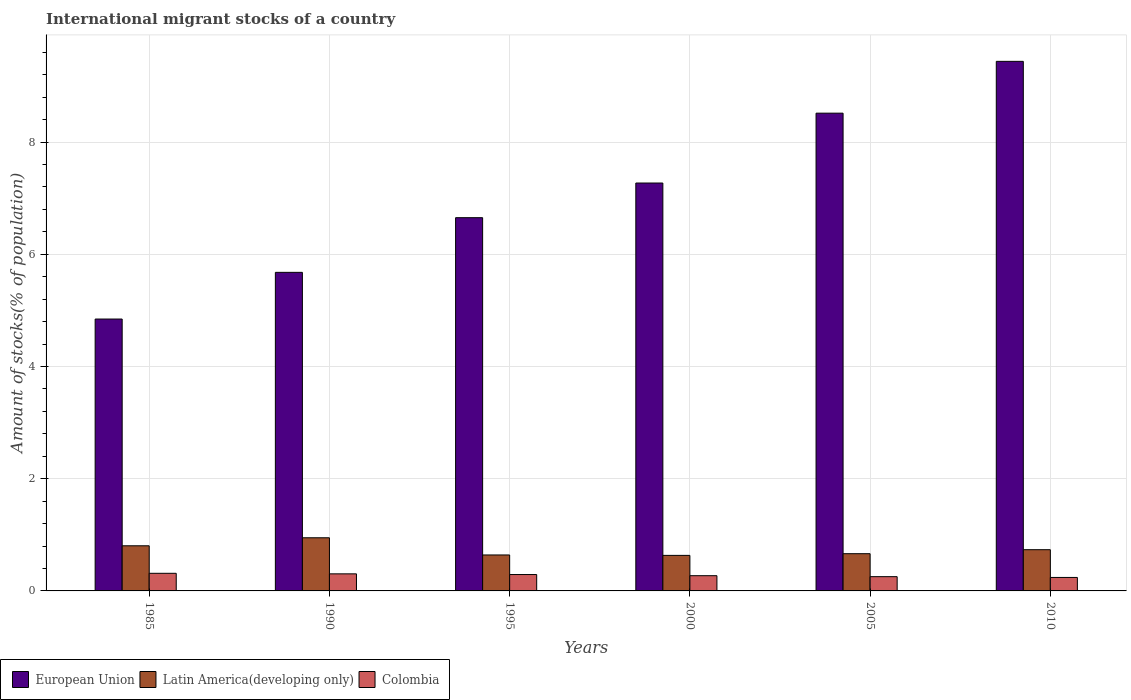How many different coloured bars are there?
Keep it short and to the point. 3. Are the number of bars on each tick of the X-axis equal?
Your response must be concise. Yes. How many bars are there on the 4th tick from the right?
Provide a short and direct response. 3. What is the label of the 6th group of bars from the left?
Make the answer very short. 2010. In how many cases, is the number of bars for a given year not equal to the number of legend labels?
Keep it short and to the point. 0. What is the amount of stocks in in Colombia in 1990?
Give a very brief answer. 0.3. Across all years, what is the maximum amount of stocks in in Colombia?
Make the answer very short. 0.31. Across all years, what is the minimum amount of stocks in in European Union?
Offer a very short reply. 4.85. In which year was the amount of stocks in in European Union maximum?
Give a very brief answer. 2010. In which year was the amount of stocks in in Colombia minimum?
Ensure brevity in your answer.  2010. What is the total amount of stocks in in Colombia in the graph?
Ensure brevity in your answer.  1.68. What is the difference between the amount of stocks in in Latin America(developing only) in 2000 and that in 2010?
Provide a short and direct response. -0.1. What is the difference between the amount of stocks in in Colombia in 2005 and the amount of stocks in in Latin America(developing only) in 1990?
Ensure brevity in your answer.  -0.69. What is the average amount of stocks in in Colombia per year?
Provide a short and direct response. 0.28. In the year 2010, what is the difference between the amount of stocks in in Latin America(developing only) and amount of stocks in in Colombia?
Keep it short and to the point. 0.49. In how many years, is the amount of stocks in in European Union greater than 6 %?
Make the answer very short. 4. What is the ratio of the amount of stocks in in European Union in 1990 to that in 1995?
Your response must be concise. 0.85. Is the difference between the amount of stocks in in Latin America(developing only) in 1995 and 2000 greater than the difference between the amount of stocks in in Colombia in 1995 and 2000?
Keep it short and to the point. No. What is the difference between the highest and the second highest amount of stocks in in Colombia?
Provide a succinct answer. 0.01. What is the difference between the highest and the lowest amount of stocks in in European Union?
Offer a very short reply. 4.59. What does the 1st bar from the left in 1995 represents?
Ensure brevity in your answer.  European Union. What does the 2nd bar from the right in 1990 represents?
Give a very brief answer. Latin America(developing only). Is it the case that in every year, the sum of the amount of stocks in in European Union and amount of stocks in in Colombia is greater than the amount of stocks in in Latin America(developing only)?
Provide a short and direct response. Yes. How many bars are there?
Make the answer very short. 18. How many years are there in the graph?
Make the answer very short. 6. What is the difference between two consecutive major ticks on the Y-axis?
Offer a terse response. 2. Are the values on the major ticks of Y-axis written in scientific E-notation?
Provide a short and direct response. No. Does the graph contain any zero values?
Give a very brief answer. No. How are the legend labels stacked?
Keep it short and to the point. Horizontal. What is the title of the graph?
Your response must be concise. International migrant stocks of a country. Does "Venezuela" appear as one of the legend labels in the graph?
Provide a short and direct response. No. What is the label or title of the X-axis?
Your answer should be very brief. Years. What is the label or title of the Y-axis?
Ensure brevity in your answer.  Amount of stocks(% of population). What is the Amount of stocks(% of population) in European Union in 1985?
Your response must be concise. 4.85. What is the Amount of stocks(% of population) in Latin America(developing only) in 1985?
Your answer should be compact. 0.8. What is the Amount of stocks(% of population) in Colombia in 1985?
Offer a terse response. 0.31. What is the Amount of stocks(% of population) of European Union in 1990?
Keep it short and to the point. 5.68. What is the Amount of stocks(% of population) of Latin America(developing only) in 1990?
Offer a very short reply. 0.95. What is the Amount of stocks(% of population) in Colombia in 1990?
Ensure brevity in your answer.  0.3. What is the Amount of stocks(% of population) in European Union in 1995?
Offer a terse response. 6.65. What is the Amount of stocks(% of population) of Latin America(developing only) in 1995?
Your answer should be compact. 0.64. What is the Amount of stocks(% of population) of Colombia in 1995?
Offer a terse response. 0.29. What is the Amount of stocks(% of population) of European Union in 2000?
Your answer should be compact. 7.27. What is the Amount of stocks(% of population) of Latin America(developing only) in 2000?
Offer a terse response. 0.63. What is the Amount of stocks(% of population) in Colombia in 2000?
Provide a succinct answer. 0.27. What is the Amount of stocks(% of population) of European Union in 2005?
Offer a very short reply. 8.51. What is the Amount of stocks(% of population) in Latin America(developing only) in 2005?
Keep it short and to the point. 0.66. What is the Amount of stocks(% of population) of Colombia in 2005?
Offer a very short reply. 0.25. What is the Amount of stocks(% of population) in European Union in 2010?
Provide a short and direct response. 9.44. What is the Amount of stocks(% of population) in Latin America(developing only) in 2010?
Provide a short and direct response. 0.73. What is the Amount of stocks(% of population) in Colombia in 2010?
Keep it short and to the point. 0.24. Across all years, what is the maximum Amount of stocks(% of population) in European Union?
Your response must be concise. 9.44. Across all years, what is the maximum Amount of stocks(% of population) in Latin America(developing only)?
Keep it short and to the point. 0.95. Across all years, what is the maximum Amount of stocks(% of population) of Colombia?
Make the answer very short. 0.31. Across all years, what is the minimum Amount of stocks(% of population) of European Union?
Keep it short and to the point. 4.85. Across all years, what is the minimum Amount of stocks(% of population) of Latin America(developing only)?
Ensure brevity in your answer.  0.63. Across all years, what is the minimum Amount of stocks(% of population) in Colombia?
Offer a very short reply. 0.24. What is the total Amount of stocks(% of population) in European Union in the graph?
Offer a very short reply. 42.4. What is the total Amount of stocks(% of population) of Latin America(developing only) in the graph?
Your answer should be very brief. 4.42. What is the total Amount of stocks(% of population) of Colombia in the graph?
Provide a succinct answer. 1.68. What is the difference between the Amount of stocks(% of population) in European Union in 1985 and that in 1990?
Make the answer very short. -0.83. What is the difference between the Amount of stocks(% of population) of Latin America(developing only) in 1985 and that in 1990?
Keep it short and to the point. -0.14. What is the difference between the Amount of stocks(% of population) in Colombia in 1985 and that in 1990?
Your answer should be very brief. 0.01. What is the difference between the Amount of stocks(% of population) of European Union in 1985 and that in 1995?
Your answer should be very brief. -1.81. What is the difference between the Amount of stocks(% of population) in Latin America(developing only) in 1985 and that in 1995?
Offer a very short reply. 0.16. What is the difference between the Amount of stocks(% of population) of Colombia in 1985 and that in 1995?
Keep it short and to the point. 0.02. What is the difference between the Amount of stocks(% of population) in European Union in 1985 and that in 2000?
Provide a short and direct response. -2.42. What is the difference between the Amount of stocks(% of population) in Latin America(developing only) in 1985 and that in 2000?
Offer a very short reply. 0.17. What is the difference between the Amount of stocks(% of population) of Colombia in 1985 and that in 2000?
Keep it short and to the point. 0.04. What is the difference between the Amount of stocks(% of population) in European Union in 1985 and that in 2005?
Keep it short and to the point. -3.67. What is the difference between the Amount of stocks(% of population) in Latin America(developing only) in 1985 and that in 2005?
Your response must be concise. 0.14. What is the difference between the Amount of stocks(% of population) of Colombia in 1985 and that in 2005?
Your answer should be very brief. 0.06. What is the difference between the Amount of stocks(% of population) in European Union in 1985 and that in 2010?
Give a very brief answer. -4.59. What is the difference between the Amount of stocks(% of population) in Latin America(developing only) in 1985 and that in 2010?
Keep it short and to the point. 0.07. What is the difference between the Amount of stocks(% of population) of Colombia in 1985 and that in 2010?
Keep it short and to the point. 0.07. What is the difference between the Amount of stocks(% of population) in European Union in 1990 and that in 1995?
Your response must be concise. -0.97. What is the difference between the Amount of stocks(% of population) of Latin America(developing only) in 1990 and that in 1995?
Offer a very short reply. 0.31. What is the difference between the Amount of stocks(% of population) in Colombia in 1990 and that in 1995?
Give a very brief answer. 0.01. What is the difference between the Amount of stocks(% of population) in European Union in 1990 and that in 2000?
Your answer should be compact. -1.59. What is the difference between the Amount of stocks(% of population) of Latin America(developing only) in 1990 and that in 2000?
Provide a succinct answer. 0.31. What is the difference between the Amount of stocks(% of population) in Colombia in 1990 and that in 2000?
Provide a short and direct response. 0.03. What is the difference between the Amount of stocks(% of population) of European Union in 1990 and that in 2005?
Your answer should be very brief. -2.84. What is the difference between the Amount of stocks(% of population) in Latin America(developing only) in 1990 and that in 2005?
Your response must be concise. 0.28. What is the difference between the Amount of stocks(% of population) in Colombia in 1990 and that in 2005?
Give a very brief answer. 0.05. What is the difference between the Amount of stocks(% of population) of European Union in 1990 and that in 2010?
Provide a succinct answer. -3.76. What is the difference between the Amount of stocks(% of population) in Latin America(developing only) in 1990 and that in 2010?
Make the answer very short. 0.21. What is the difference between the Amount of stocks(% of population) in Colombia in 1990 and that in 2010?
Make the answer very short. 0.06. What is the difference between the Amount of stocks(% of population) in European Union in 1995 and that in 2000?
Make the answer very short. -0.62. What is the difference between the Amount of stocks(% of population) in Latin America(developing only) in 1995 and that in 2000?
Your response must be concise. 0.01. What is the difference between the Amount of stocks(% of population) of Colombia in 1995 and that in 2000?
Your answer should be compact. 0.02. What is the difference between the Amount of stocks(% of population) of European Union in 1995 and that in 2005?
Give a very brief answer. -1.86. What is the difference between the Amount of stocks(% of population) of Latin America(developing only) in 1995 and that in 2005?
Give a very brief answer. -0.02. What is the difference between the Amount of stocks(% of population) of Colombia in 1995 and that in 2005?
Give a very brief answer. 0.04. What is the difference between the Amount of stocks(% of population) of European Union in 1995 and that in 2010?
Your response must be concise. -2.79. What is the difference between the Amount of stocks(% of population) of Latin America(developing only) in 1995 and that in 2010?
Provide a short and direct response. -0.09. What is the difference between the Amount of stocks(% of population) of Colombia in 1995 and that in 2010?
Make the answer very short. 0.05. What is the difference between the Amount of stocks(% of population) in European Union in 2000 and that in 2005?
Provide a succinct answer. -1.25. What is the difference between the Amount of stocks(% of population) of Latin America(developing only) in 2000 and that in 2005?
Keep it short and to the point. -0.03. What is the difference between the Amount of stocks(% of population) in Colombia in 2000 and that in 2005?
Offer a terse response. 0.02. What is the difference between the Amount of stocks(% of population) in European Union in 2000 and that in 2010?
Make the answer very short. -2.17. What is the difference between the Amount of stocks(% of population) of Latin America(developing only) in 2000 and that in 2010?
Provide a succinct answer. -0.1. What is the difference between the Amount of stocks(% of population) of Colombia in 2000 and that in 2010?
Provide a succinct answer. 0.03. What is the difference between the Amount of stocks(% of population) of European Union in 2005 and that in 2010?
Make the answer very short. -0.92. What is the difference between the Amount of stocks(% of population) of Latin America(developing only) in 2005 and that in 2010?
Provide a short and direct response. -0.07. What is the difference between the Amount of stocks(% of population) in Colombia in 2005 and that in 2010?
Give a very brief answer. 0.01. What is the difference between the Amount of stocks(% of population) of European Union in 1985 and the Amount of stocks(% of population) of Latin America(developing only) in 1990?
Your answer should be very brief. 3.9. What is the difference between the Amount of stocks(% of population) in European Union in 1985 and the Amount of stocks(% of population) in Colombia in 1990?
Keep it short and to the point. 4.54. What is the difference between the Amount of stocks(% of population) in Latin America(developing only) in 1985 and the Amount of stocks(% of population) in Colombia in 1990?
Your answer should be very brief. 0.5. What is the difference between the Amount of stocks(% of population) of European Union in 1985 and the Amount of stocks(% of population) of Latin America(developing only) in 1995?
Your response must be concise. 4.2. What is the difference between the Amount of stocks(% of population) of European Union in 1985 and the Amount of stocks(% of population) of Colombia in 1995?
Make the answer very short. 4.55. What is the difference between the Amount of stocks(% of population) of Latin America(developing only) in 1985 and the Amount of stocks(% of population) of Colombia in 1995?
Give a very brief answer. 0.51. What is the difference between the Amount of stocks(% of population) of European Union in 1985 and the Amount of stocks(% of population) of Latin America(developing only) in 2000?
Offer a very short reply. 4.21. What is the difference between the Amount of stocks(% of population) in European Union in 1985 and the Amount of stocks(% of population) in Colombia in 2000?
Provide a short and direct response. 4.57. What is the difference between the Amount of stocks(% of population) in Latin America(developing only) in 1985 and the Amount of stocks(% of population) in Colombia in 2000?
Your response must be concise. 0.53. What is the difference between the Amount of stocks(% of population) of European Union in 1985 and the Amount of stocks(% of population) of Latin America(developing only) in 2005?
Your answer should be compact. 4.18. What is the difference between the Amount of stocks(% of population) in European Union in 1985 and the Amount of stocks(% of population) in Colombia in 2005?
Provide a succinct answer. 4.59. What is the difference between the Amount of stocks(% of population) of Latin America(developing only) in 1985 and the Amount of stocks(% of population) of Colombia in 2005?
Provide a short and direct response. 0.55. What is the difference between the Amount of stocks(% of population) in European Union in 1985 and the Amount of stocks(% of population) in Latin America(developing only) in 2010?
Offer a terse response. 4.11. What is the difference between the Amount of stocks(% of population) of European Union in 1985 and the Amount of stocks(% of population) of Colombia in 2010?
Keep it short and to the point. 4.61. What is the difference between the Amount of stocks(% of population) in Latin America(developing only) in 1985 and the Amount of stocks(% of population) in Colombia in 2010?
Provide a short and direct response. 0.56. What is the difference between the Amount of stocks(% of population) of European Union in 1990 and the Amount of stocks(% of population) of Latin America(developing only) in 1995?
Ensure brevity in your answer.  5.04. What is the difference between the Amount of stocks(% of population) in European Union in 1990 and the Amount of stocks(% of population) in Colombia in 1995?
Provide a short and direct response. 5.39. What is the difference between the Amount of stocks(% of population) in Latin America(developing only) in 1990 and the Amount of stocks(% of population) in Colombia in 1995?
Offer a terse response. 0.66. What is the difference between the Amount of stocks(% of population) in European Union in 1990 and the Amount of stocks(% of population) in Latin America(developing only) in 2000?
Your response must be concise. 5.04. What is the difference between the Amount of stocks(% of population) in European Union in 1990 and the Amount of stocks(% of population) in Colombia in 2000?
Provide a succinct answer. 5.41. What is the difference between the Amount of stocks(% of population) of Latin America(developing only) in 1990 and the Amount of stocks(% of population) of Colombia in 2000?
Offer a terse response. 0.68. What is the difference between the Amount of stocks(% of population) of European Union in 1990 and the Amount of stocks(% of population) of Latin America(developing only) in 2005?
Your answer should be compact. 5.01. What is the difference between the Amount of stocks(% of population) in European Union in 1990 and the Amount of stocks(% of population) in Colombia in 2005?
Give a very brief answer. 5.42. What is the difference between the Amount of stocks(% of population) of Latin America(developing only) in 1990 and the Amount of stocks(% of population) of Colombia in 2005?
Make the answer very short. 0.69. What is the difference between the Amount of stocks(% of population) of European Union in 1990 and the Amount of stocks(% of population) of Latin America(developing only) in 2010?
Offer a terse response. 4.94. What is the difference between the Amount of stocks(% of population) in European Union in 1990 and the Amount of stocks(% of population) in Colombia in 2010?
Keep it short and to the point. 5.44. What is the difference between the Amount of stocks(% of population) of Latin America(developing only) in 1990 and the Amount of stocks(% of population) of Colombia in 2010?
Your answer should be very brief. 0.71. What is the difference between the Amount of stocks(% of population) of European Union in 1995 and the Amount of stocks(% of population) of Latin America(developing only) in 2000?
Provide a short and direct response. 6.02. What is the difference between the Amount of stocks(% of population) in European Union in 1995 and the Amount of stocks(% of population) in Colombia in 2000?
Provide a succinct answer. 6.38. What is the difference between the Amount of stocks(% of population) in Latin America(developing only) in 1995 and the Amount of stocks(% of population) in Colombia in 2000?
Offer a terse response. 0.37. What is the difference between the Amount of stocks(% of population) of European Union in 1995 and the Amount of stocks(% of population) of Latin America(developing only) in 2005?
Offer a terse response. 5.99. What is the difference between the Amount of stocks(% of population) in European Union in 1995 and the Amount of stocks(% of population) in Colombia in 2005?
Keep it short and to the point. 6.4. What is the difference between the Amount of stocks(% of population) in Latin America(developing only) in 1995 and the Amount of stocks(% of population) in Colombia in 2005?
Offer a very short reply. 0.39. What is the difference between the Amount of stocks(% of population) in European Union in 1995 and the Amount of stocks(% of population) in Latin America(developing only) in 2010?
Ensure brevity in your answer.  5.92. What is the difference between the Amount of stocks(% of population) in European Union in 1995 and the Amount of stocks(% of population) in Colombia in 2010?
Keep it short and to the point. 6.41. What is the difference between the Amount of stocks(% of population) of Latin America(developing only) in 1995 and the Amount of stocks(% of population) of Colombia in 2010?
Your answer should be very brief. 0.4. What is the difference between the Amount of stocks(% of population) in European Union in 2000 and the Amount of stocks(% of population) in Latin America(developing only) in 2005?
Provide a short and direct response. 6.61. What is the difference between the Amount of stocks(% of population) of European Union in 2000 and the Amount of stocks(% of population) of Colombia in 2005?
Provide a succinct answer. 7.02. What is the difference between the Amount of stocks(% of population) of Latin America(developing only) in 2000 and the Amount of stocks(% of population) of Colombia in 2005?
Offer a very short reply. 0.38. What is the difference between the Amount of stocks(% of population) in European Union in 2000 and the Amount of stocks(% of population) in Latin America(developing only) in 2010?
Ensure brevity in your answer.  6.53. What is the difference between the Amount of stocks(% of population) of European Union in 2000 and the Amount of stocks(% of population) of Colombia in 2010?
Provide a short and direct response. 7.03. What is the difference between the Amount of stocks(% of population) of Latin America(developing only) in 2000 and the Amount of stocks(% of population) of Colombia in 2010?
Ensure brevity in your answer.  0.39. What is the difference between the Amount of stocks(% of population) in European Union in 2005 and the Amount of stocks(% of population) in Latin America(developing only) in 2010?
Make the answer very short. 7.78. What is the difference between the Amount of stocks(% of population) of European Union in 2005 and the Amount of stocks(% of population) of Colombia in 2010?
Ensure brevity in your answer.  8.27. What is the difference between the Amount of stocks(% of population) of Latin America(developing only) in 2005 and the Amount of stocks(% of population) of Colombia in 2010?
Provide a short and direct response. 0.42. What is the average Amount of stocks(% of population) of European Union per year?
Your answer should be compact. 7.07. What is the average Amount of stocks(% of population) in Latin America(developing only) per year?
Provide a short and direct response. 0.74. What is the average Amount of stocks(% of population) in Colombia per year?
Provide a short and direct response. 0.28. In the year 1985, what is the difference between the Amount of stocks(% of population) in European Union and Amount of stocks(% of population) in Latin America(developing only)?
Offer a very short reply. 4.04. In the year 1985, what is the difference between the Amount of stocks(% of population) in European Union and Amount of stocks(% of population) in Colombia?
Your answer should be very brief. 4.53. In the year 1985, what is the difference between the Amount of stocks(% of population) of Latin America(developing only) and Amount of stocks(% of population) of Colombia?
Make the answer very short. 0.49. In the year 1990, what is the difference between the Amount of stocks(% of population) in European Union and Amount of stocks(% of population) in Latin America(developing only)?
Your answer should be very brief. 4.73. In the year 1990, what is the difference between the Amount of stocks(% of population) in European Union and Amount of stocks(% of population) in Colombia?
Make the answer very short. 5.37. In the year 1990, what is the difference between the Amount of stocks(% of population) in Latin America(developing only) and Amount of stocks(% of population) in Colombia?
Your answer should be very brief. 0.64. In the year 1995, what is the difference between the Amount of stocks(% of population) in European Union and Amount of stocks(% of population) in Latin America(developing only)?
Offer a terse response. 6.01. In the year 1995, what is the difference between the Amount of stocks(% of population) of European Union and Amount of stocks(% of population) of Colombia?
Make the answer very short. 6.36. In the year 1995, what is the difference between the Amount of stocks(% of population) in Latin America(developing only) and Amount of stocks(% of population) in Colombia?
Provide a succinct answer. 0.35. In the year 2000, what is the difference between the Amount of stocks(% of population) of European Union and Amount of stocks(% of population) of Latin America(developing only)?
Offer a terse response. 6.64. In the year 2000, what is the difference between the Amount of stocks(% of population) in European Union and Amount of stocks(% of population) in Colombia?
Your answer should be very brief. 7. In the year 2000, what is the difference between the Amount of stocks(% of population) of Latin America(developing only) and Amount of stocks(% of population) of Colombia?
Your response must be concise. 0.36. In the year 2005, what is the difference between the Amount of stocks(% of population) in European Union and Amount of stocks(% of population) in Latin America(developing only)?
Offer a terse response. 7.85. In the year 2005, what is the difference between the Amount of stocks(% of population) of European Union and Amount of stocks(% of population) of Colombia?
Provide a short and direct response. 8.26. In the year 2005, what is the difference between the Amount of stocks(% of population) of Latin America(developing only) and Amount of stocks(% of population) of Colombia?
Provide a succinct answer. 0.41. In the year 2010, what is the difference between the Amount of stocks(% of population) of European Union and Amount of stocks(% of population) of Latin America(developing only)?
Your answer should be very brief. 8.7. In the year 2010, what is the difference between the Amount of stocks(% of population) in European Union and Amount of stocks(% of population) in Colombia?
Keep it short and to the point. 9.2. In the year 2010, what is the difference between the Amount of stocks(% of population) in Latin America(developing only) and Amount of stocks(% of population) in Colombia?
Make the answer very short. 0.49. What is the ratio of the Amount of stocks(% of population) of European Union in 1985 to that in 1990?
Ensure brevity in your answer.  0.85. What is the ratio of the Amount of stocks(% of population) of Latin America(developing only) in 1985 to that in 1990?
Provide a short and direct response. 0.85. What is the ratio of the Amount of stocks(% of population) of Colombia in 1985 to that in 1990?
Provide a short and direct response. 1.03. What is the ratio of the Amount of stocks(% of population) in European Union in 1985 to that in 1995?
Offer a terse response. 0.73. What is the ratio of the Amount of stocks(% of population) of Latin America(developing only) in 1985 to that in 1995?
Offer a very short reply. 1.26. What is the ratio of the Amount of stocks(% of population) in Colombia in 1985 to that in 1995?
Offer a very short reply. 1.08. What is the ratio of the Amount of stocks(% of population) of European Union in 1985 to that in 2000?
Provide a succinct answer. 0.67. What is the ratio of the Amount of stocks(% of population) of Latin America(developing only) in 1985 to that in 2000?
Offer a very short reply. 1.27. What is the ratio of the Amount of stocks(% of population) in Colombia in 1985 to that in 2000?
Your answer should be very brief. 1.16. What is the ratio of the Amount of stocks(% of population) of European Union in 1985 to that in 2005?
Your answer should be compact. 0.57. What is the ratio of the Amount of stocks(% of population) in Latin America(developing only) in 1985 to that in 2005?
Your answer should be compact. 1.21. What is the ratio of the Amount of stocks(% of population) of Colombia in 1985 to that in 2005?
Offer a very short reply. 1.24. What is the ratio of the Amount of stocks(% of population) in European Union in 1985 to that in 2010?
Provide a short and direct response. 0.51. What is the ratio of the Amount of stocks(% of population) of Latin America(developing only) in 1985 to that in 2010?
Provide a short and direct response. 1.09. What is the ratio of the Amount of stocks(% of population) in Colombia in 1985 to that in 2010?
Your answer should be very brief. 1.31. What is the ratio of the Amount of stocks(% of population) in European Union in 1990 to that in 1995?
Ensure brevity in your answer.  0.85. What is the ratio of the Amount of stocks(% of population) of Latin America(developing only) in 1990 to that in 1995?
Keep it short and to the point. 1.48. What is the ratio of the Amount of stocks(% of population) in Colombia in 1990 to that in 1995?
Give a very brief answer. 1.04. What is the ratio of the Amount of stocks(% of population) in European Union in 1990 to that in 2000?
Give a very brief answer. 0.78. What is the ratio of the Amount of stocks(% of population) of Latin America(developing only) in 1990 to that in 2000?
Make the answer very short. 1.5. What is the ratio of the Amount of stocks(% of population) of Colombia in 1990 to that in 2000?
Offer a terse response. 1.12. What is the ratio of the Amount of stocks(% of population) in European Union in 1990 to that in 2005?
Ensure brevity in your answer.  0.67. What is the ratio of the Amount of stocks(% of population) in Latin America(developing only) in 1990 to that in 2005?
Provide a short and direct response. 1.43. What is the ratio of the Amount of stocks(% of population) in Colombia in 1990 to that in 2005?
Provide a short and direct response. 1.2. What is the ratio of the Amount of stocks(% of population) of European Union in 1990 to that in 2010?
Your answer should be very brief. 0.6. What is the ratio of the Amount of stocks(% of population) in Latin America(developing only) in 1990 to that in 2010?
Provide a short and direct response. 1.29. What is the ratio of the Amount of stocks(% of population) of Colombia in 1990 to that in 2010?
Offer a very short reply. 1.27. What is the ratio of the Amount of stocks(% of population) in European Union in 1995 to that in 2000?
Your response must be concise. 0.92. What is the ratio of the Amount of stocks(% of population) in Latin America(developing only) in 1995 to that in 2000?
Provide a short and direct response. 1.01. What is the ratio of the Amount of stocks(% of population) in Colombia in 1995 to that in 2000?
Your answer should be very brief. 1.08. What is the ratio of the Amount of stocks(% of population) in European Union in 1995 to that in 2005?
Offer a very short reply. 0.78. What is the ratio of the Amount of stocks(% of population) in Latin America(developing only) in 1995 to that in 2005?
Your answer should be compact. 0.97. What is the ratio of the Amount of stocks(% of population) in Colombia in 1995 to that in 2005?
Provide a short and direct response. 1.15. What is the ratio of the Amount of stocks(% of population) in European Union in 1995 to that in 2010?
Keep it short and to the point. 0.7. What is the ratio of the Amount of stocks(% of population) in Latin America(developing only) in 1995 to that in 2010?
Your answer should be very brief. 0.87. What is the ratio of the Amount of stocks(% of population) of Colombia in 1995 to that in 2010?
Your response must be concise. 1.21. What is the ratio of the Amount of stocks(% of population) in European Union in 2000 to that in 2005?
Your answer should be compact. 0.85. What is the ratio of the Amount of stocks(% of population) of Latin America(developing only) in 2000 to that in 2005?
Your answer should be compact. 0.95. What is the ratio of the Amount of stocks(% of population) of Colombia in 2000 to that in 2005?
Offer a terse response. 1.07. What is the ratio of the Amount of stocks(% of population) of European Union in 2000 to that in 2010?
Offer a terse response. 0.77. What is the ratio of the Amount of stocks(% of population) of Latin America(developing only) in 2000 to that in 2010?
Provide a succinct answer. 0.86. What is the ratio of the Amount of stocks(% of population) in Colombia in 2000 to that in 2010?
Give a very brief answer. 1.13. What is the ratio of the Amount of stocks(% of population) in European Union in 2005 to that in 2010?
Provide a succinct answer. 0.9. What is the ratio of the Amount of stocks(% of population) of Latin America(developing only) in 2005 to that in 2010?
Keep it short and to the point. 0.9. What is the ratio of the Amount of stocks(% of population) in Colombia in 2005 to that in 2010?
Give a very brief answer. 1.06. What is the difference between the highest and the second highest Amount of stocks(% of population) of European Union?
Offer a very short reply. 0.92. What is the difference between the highest and the second highest Amount of stocks(% of population) of Latin America(developing only)?
Your answer should be compact. 0.14. What is the difference between the highest and the second highest Amount of stocks(% of population) in Colombia?
Your response must be concise. 0.01. What is the difference between the highest and the lowest Amount of stocks(% of population) of European Union?
Offer a terse response. 4.59. What is the difference between the highest and the lowest Amount of stocks(% of population) of Latin America(developing only)?
Give a very brief answer. 0.31. What is the difference between the highest and the lowest Amount of stocks(% of population) in Colombia?
Your answer should be compact. 0.07. 